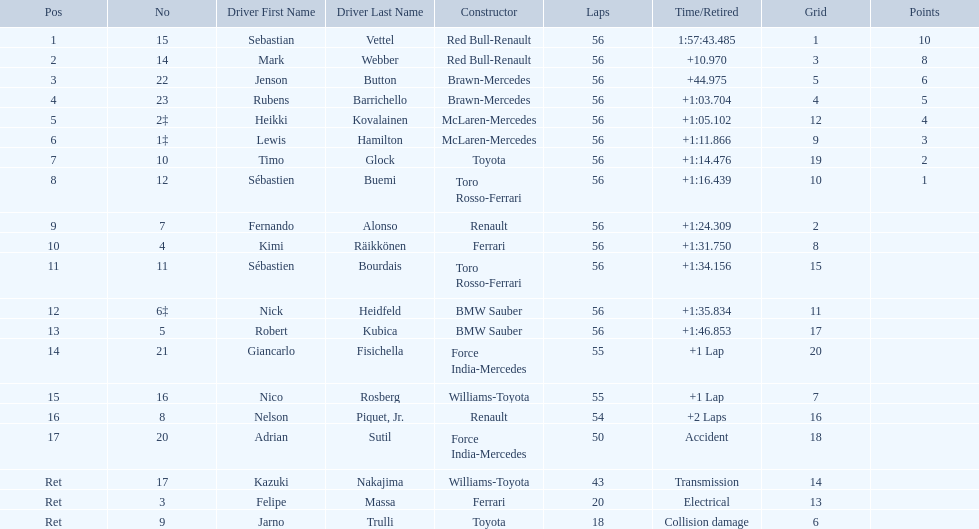Which drive retired because of electrical issues? Felipe Massa. Which driver retired due to accident? Adrian Sutil. Which driver retired due to collision damage? Jarno Trulli. Could you parse the entire table as a dict? {'header': ['Pos', 'No', 'Driver First Name', 'Driver Last Name', 'Constructor', 'Laps', 'Time/Retired', 'Grid', 'Points'], 'rows': [['1', '15', 'Sebastian', 'Vettel', 'Red Bull-Renault', '56', '1:57:43.485', '1', '10'], ['2', '14', 'Mark', 'Webber', 'Red Bull-Renault', '56', '+10.970', '3', '8'], ['3', '22', 'Jenson', 'Button', 'Brawn-Mercedes', '56', '+44.975', '5', '6'], ['4', '23', 'Rubens', 'Barrichello', 'Brawn-Mercedes', '56', '+1:03.704', '4', '5'], ['5', '2‡', 'Heikki', 'Kovalainen', 'McLaren-Mercedes', '56', '+1:05.102', '12', '4'], ['6', '1‡', 'Lewis', 'Hamilton', 'McLaren-Mercedes', '56', '+1:11.866', '9', '3'], ['7', '10', 'Timo', 'Glock', 'Toyota', '56', '+1:14.476', '19', '2'], ['8', '12', 'Sébastien', 'Buemi', 'Toro Rosso-Ferrari', '56', '+1:16.439', '10', '1'], ['9', '7', 'Fernando', 'Alonso', 'Renault', '56', '+1:24.309', '2', ''], ['10', '4', 'Kimi', 'Räikkönen', 'Ferrari', '56', '+1:31.750', '8', ''], ['11', '11', 'Sébastien', 'Bourdais', 'Toro Rosso-Ferrari', '56', '+1:34.156', '15', ''], ['12', '6‡', 'Nick', 'Heidfeld', 'BMW Sauber', '56', '+1:35.834', '11', ''], ['13', '5', 'Robert', 'Kubica', 'BMW Sauber', '56', '+1:46.853', '17', ''], ['14', '21', 'Giancarlo', 'Fisichella', 'Force India-Mercedes', '55', '+1 Lap', '20', ''], ['15', '16', 'Nico', 'Rosberg', 'Williams-Toyota', '55', '+1 Lap', '7', ''], ['16', '8', 'Nelson', 'Piquet, Jr.', 'Renault', '54', '+2 Laps', '16', ''], ['17', '20', 'Adrian', 'Sutil', 'Force India-Mercedes', '50', 'Accident', '18', ''], ['Ret', '17', 'Kazuki', 'Nakajima', 'Williams-Toyota', '43', 'Transmission', '14', ''], ['Ret', '3', 'Felipe', 'Massa', 'Ferrari', '20', 'Electrical', '13', ''], ['Ret', '9', 'Jarno', 'Trulli', 'Toyota', '18', 'Collision damage', '6', '']]} 